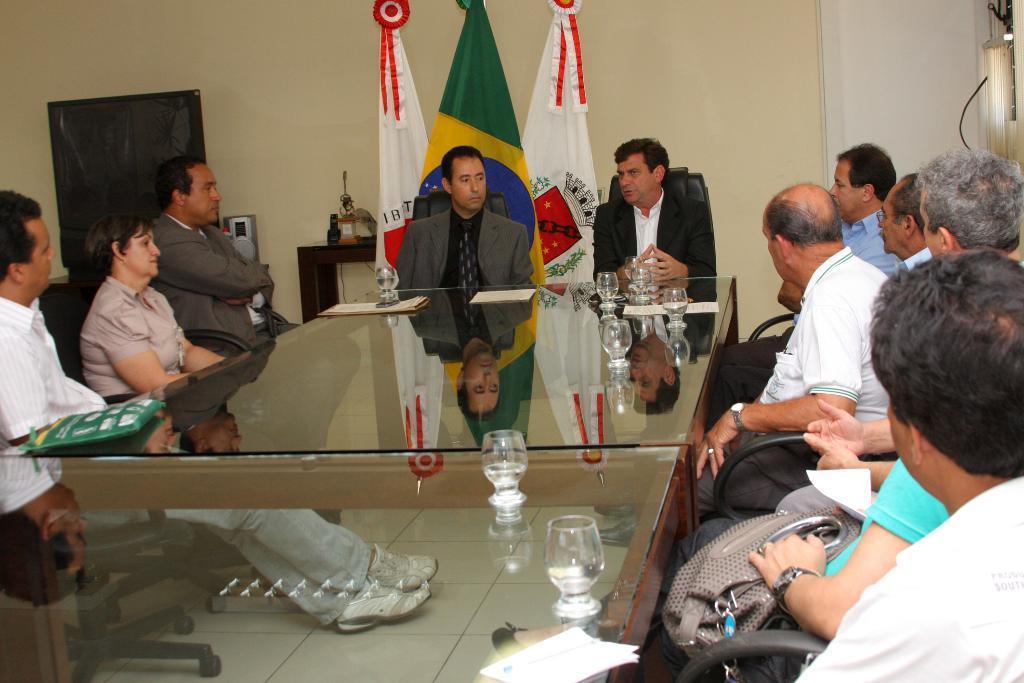How would you summarize this image in a sentence or two? Here we can see some persons are sitting on the chairs. This is table. On the table there are glasses, and papers. These are the flags and there is a door. On the background there is a wall. And this is floor. 